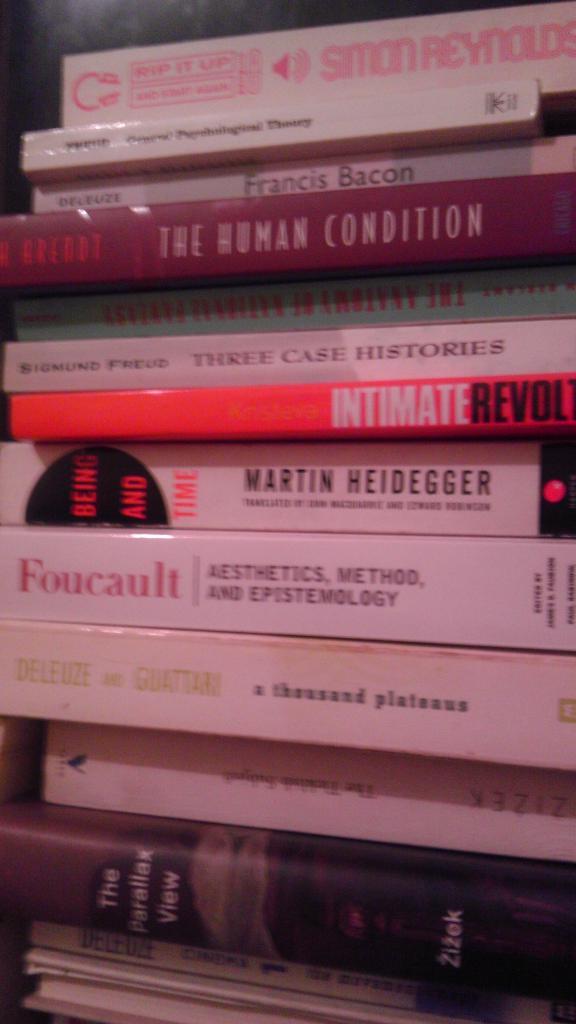What book did martin heidegger author?
Ensure brevity in your answer.  Being and time. Who wrote the top book?
Provide a short and direct response. Simon reynolds. 